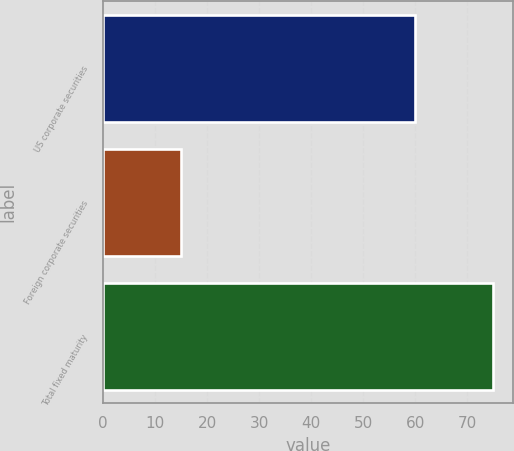Convert chart to OTSL. <chart><loc_0><loc_0><loc_500><loc_500><bar_chart><fcel>US corporate securities<fcel>Foreign corporate securities<fcel>Total fixed maturity<nl><fcel>60<fcel>15<fcel>75<nl></chart> 